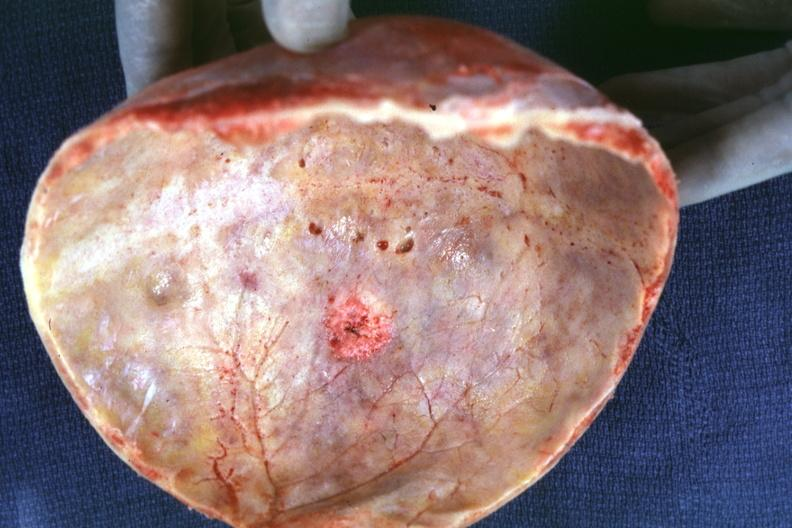s metastatic carcinoma present?
Answer the question using a single word or phrase. Yes 